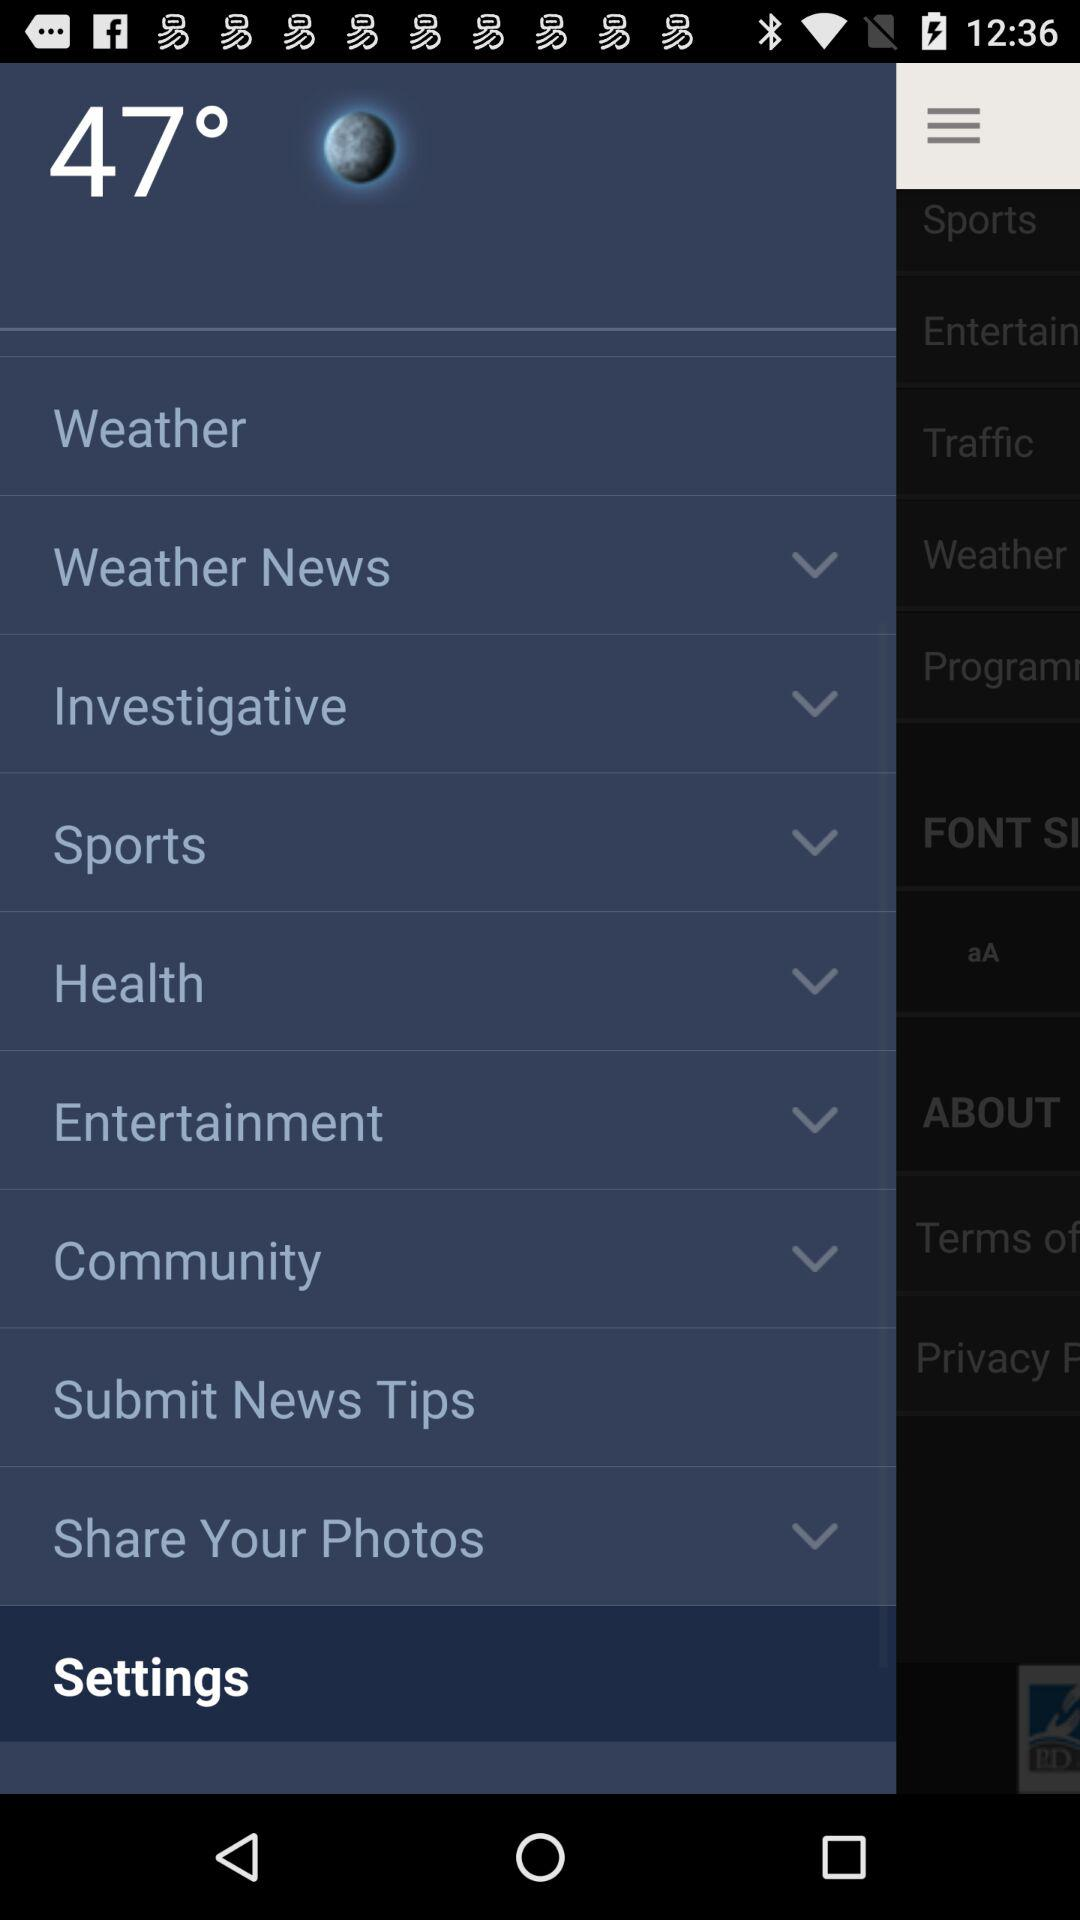What is the shown temperature? The shown temperature is 47°. 